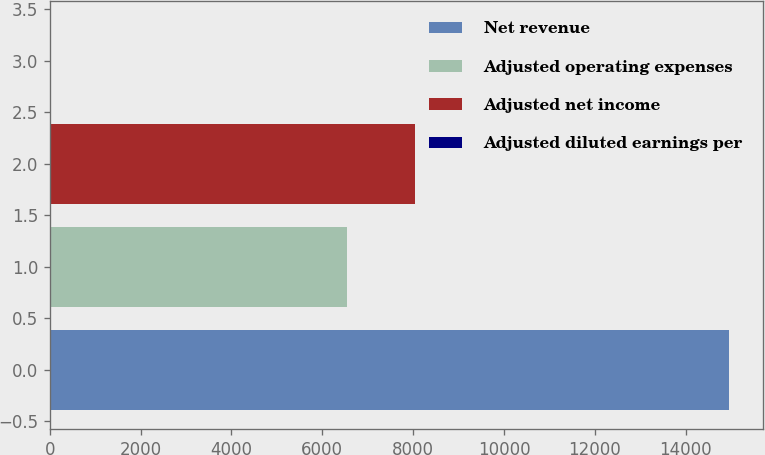Convert chart to OTSL. <chart><loc_0><loc_0><loc_500><loc_500><bar_chart><fcel>Net revenue<fcel>Adjusted operating expenses<fcel>Adjusted net income<fcel>Adjusted diluted earnings per<nl><fcel>14950<fcel>6540<fcel>8034.35<fcel>6.49<nl></chart> 